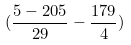<formula> <loc_0><loc_0><loc_500><loc_500>( \frac { 5 - 2 0 5 } { 2 9 } - \frac { 1 7 9 } { 4 } )</formula> 